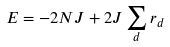Convert formula to latex. <formula><loc_0><loc_0><loc_500><loc_500>E = - 2 N J + 2 J \sum _ { d } r _ { d }</formula> 